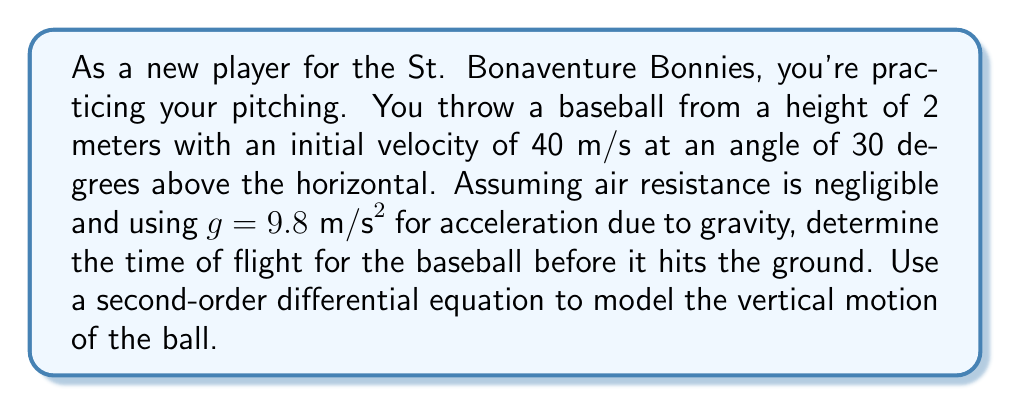Can you solve this math problem? Let's approach this step-by-step:

1) The vertical motion of the baseball can be described by the second-order differential equation:

   $$\frac{d^2y}{dt^2} = -g$$

   where $y$ is the vertical position and $t$ is time.

2) Integrating once gives us the velocity equation:

   $$\frac{dy}{dt} = -gt + v_0\sin\theta$$

   where $v_0 = 40 \text{ m/s}$ and $\theta = 30°$.

3) Integrating again gives us the position equation:

   $$y = -\frac{1}{2}gt^2 + (v_0\sin\theta)t + y_0$$

   where $y_0 = 2 \text{ m}$ (initial height).

4) We need to find $t$ when $y = 0$ (when the ball hits the ground). Substituting:

   $$0 = -\frac{1}{2}(9.8)t^2 + (40\sin30°)t + 2$$

5) Simplify:

   $$0 = -4.9t^2 + 20t + 2$$

6) This is a quadratic equation. We can solve it using the quadratic formula:

   $$t = \frac{-b \pm \sqrt{b^2 - 4ac}}{2a}$$

   where $a = -4.9$, $b = 20$, and $c = 2$

7) Substituting:

   $$t = \frac{-20 \pm \sqrt{20^2 - 4(-4.9)(2)}}{2(-4.9)}$$

8) Simplifying:

   $$t = \frac{-20 \pm \sqrt{400 + 39.2}}{-9.8} = \frac{-20 \pm \sqrt{439.2}}{-9.8}$$

9) Calculating:

   $$t \approx 4.26 \text{ or } -0.18$$

10) Since time cannot be negative in this context, we take the positive solution.
Answer: $4.26 \text{ seconds}$ 